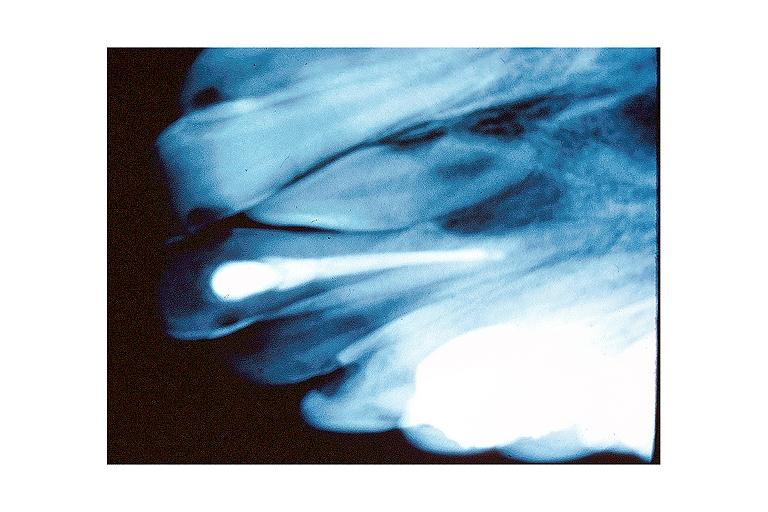what is present?
Answer the question using a single word or phrase. Oral 